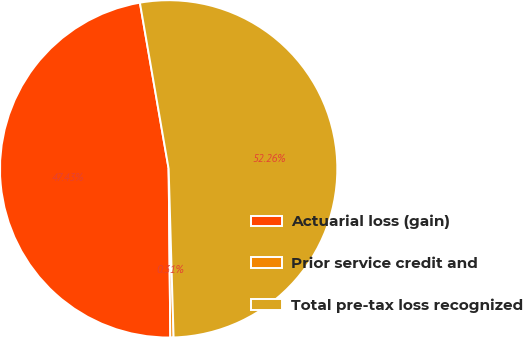Convert chart to OTSL. <chart><loc_0><loc_0><loc_500><loc_500><pie_chart><fcel>Actuarial loss (gain)<fcel>Prior service credit and<fcel>Total pre-tax loss recognized<nl><fcel>47.43%<fcel>0.31%<fcel>52.26%<nl></chart> 